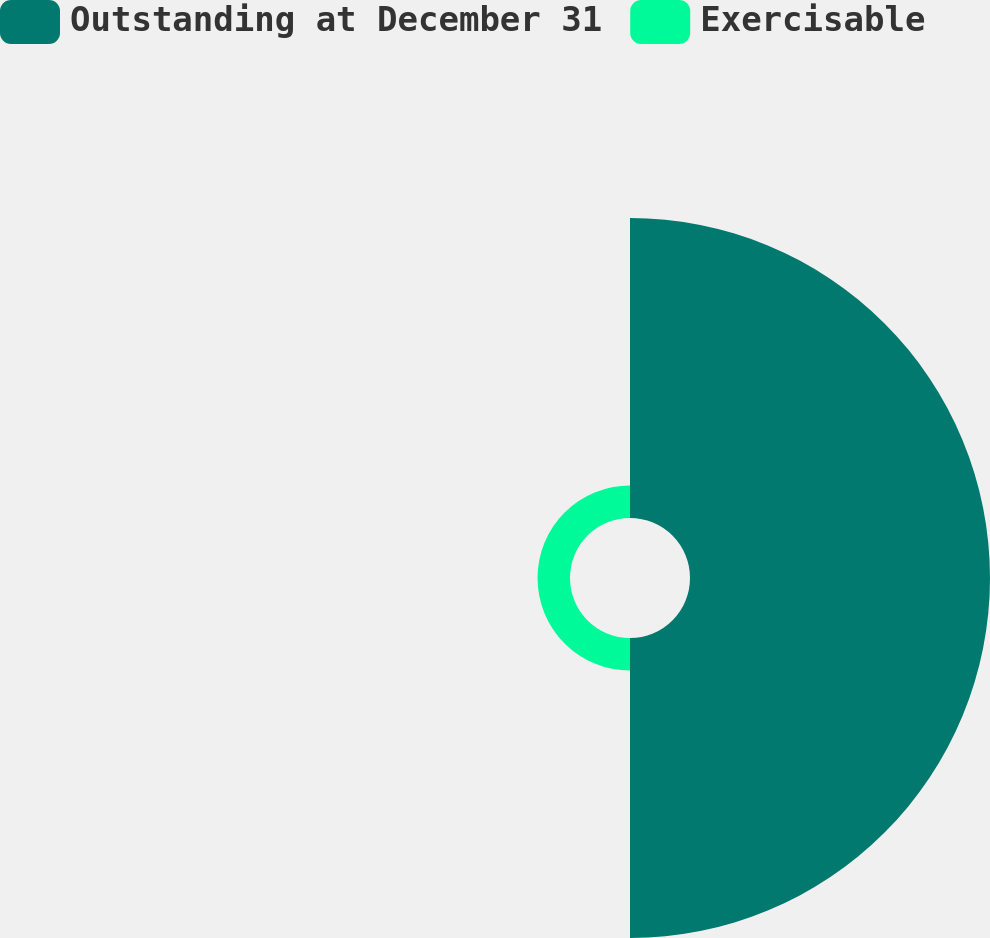Convert chart. <chart><loc_0><loc_0><loc_500><loc_500><pie_chart><fcel>Outstanding at December 31<fcel>Exercisable<nl><fcel>90.23%<fcel>9.77%<nl></chart> 